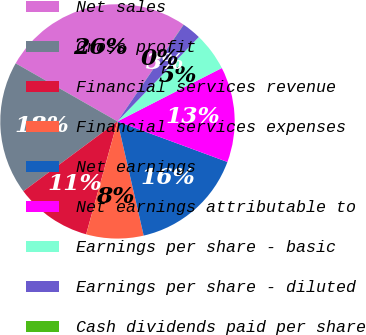Convert chart to OTSL. <chart><loc_0><loc_0><loc_500><loc_500><pie_chart><fcel>Net sales<fcel>Gross profit<fcel>Financial services revenue<fcel>Financial services expenses<fcel>Net earnings<fcel>Net earnings attributable to<fcel>Earnings per share - basic<fcel>Earnings per share - diluted<fcel>Cash dividends paid per share<nl><fcel>26.29%<fcel>18.41%<fcel>10.53%<fcel>7.9%<fcel>15.78%<fcel>13.15%<fcel>5.27%<fcel>2.65%<fcel>0.02%<nl></chart> 